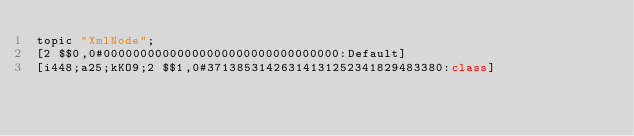Convert code to text. <code><loc_0><loc_0><loc_500><loc_500><_C++_>topic "XmlNode";
[2 $$0,0#00000000000000000000000000000000:Default]
[i448;a25;kKO9;2 $$1,0#37138531426314131252341829483380:class]</code> 